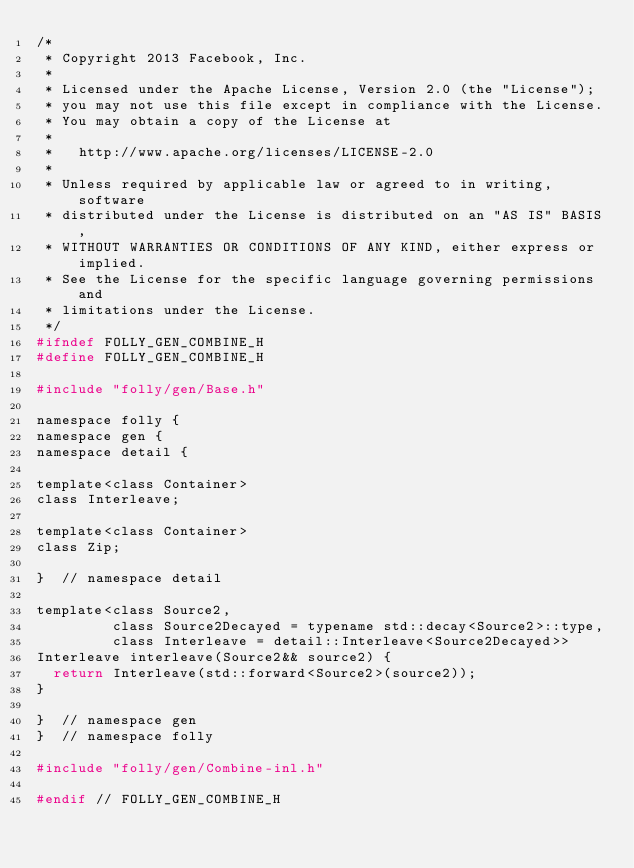<code> <loc_0><loc_0><loc_500><loc_500><_C_>/*
 * Copyright 2013 Facebook, Inc.
 *
 * Licensed under the Apache License, Version 2.0 (the "License");
 * you may not use this file except in compliance with the License.
 * You may obtain a copy of the License at
 *
 *   http://www.apache.org/licenses/LICENSE-2.0
 *
 * Unless required by applicable law or agreed to in writing, software
 * distributed under the License is distributed on an "AS IS" BASIS,
 * WITHOUT WARRANTIES OR CONDITIONS OF ANY KIND, either express or implied.
 * See the License for the specific language governing permissions and
 * limitations under the License.
 */
#ifndef FOLLY_GEN_COMBINE_H
#define FOLLY_GEN_COMBINE_H

#include "folly/gen/Base.h"

namespace folly {
namespace gen {
namespace detail {

template<class Container>
class Interleave;

template<class Container>
class Zip;

}  // namespace detail

template<class Source2,
         class Source2Decayed = typename std::decay<Source2>::type,
         class Interleave = detail::Interleave<Source2Decayed>>
Interleave interleave(Source2&& source2) {
  return Interleave(std::forward<Source2>(source2));
}

}  // namespace gen
}  // namespace folly

#include "folly/gen/Combine-inl.h"

#endif // FOLLY_GEN_COMBINE_H
</code> 